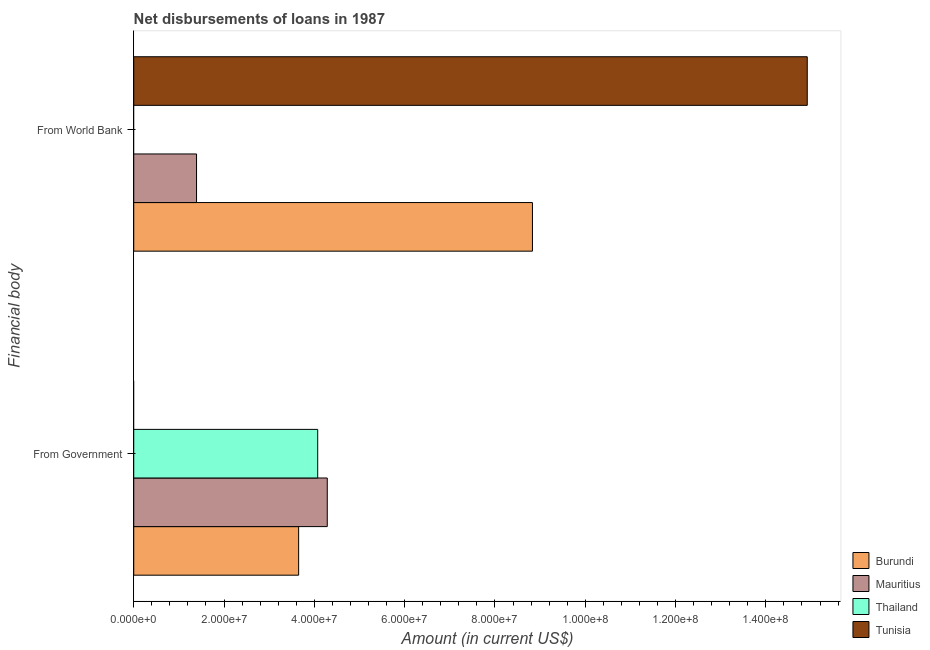How many different coloured bars are there?
Offer a very short reply. 4. Are the number of bars per tick equal to the number of legend labels?
Keep it short and to the point. No. Are the number of bars on each tick of the Y-axis equal?
Give a very brief answer. Yes. What is the label of the 2nd group of bars from the top?
Offer a very short reply. From Government. What is the net disbursements of loan from government in Mauritius?
Provide a succinct answer. 4.29e+07. Across all countries, what is the maximum net disbursements of loan from world bank?
Provide a short and direct response. 1.49e+08. In which country was the net disbursements of loan from government maximum?
Provide a succinct answer. Mauritius. What is the total net disbursements of loan from government in the graph?
Provide a short and direct response. 1.20e+08. What is the difference between the net disbursements of loan from world bank in Mauritius and that in Tunisia?
Provide a short and direct response. -1.35e+08. What is the difference between the net disbursements of loan from world bank in Burundi and the net disbursements of loan from government in Thailand?
Give a very brief answer. 4.76e+07. What is the average net disbursements of loan from government per country?
Provide a succinct answer. 3.00e+07. What is the difference between the net disbursements of loan from world bank and net disbursements of loan from government in Mauritius?
Make the answer very short. -2.89e+07. In how many countries, is the net disbursements of loan from world bank greater than 128000000 US$?
Make the answer very short. 1. What is the ratio of the net disbursements of loan from world bank in Tunisia to that in Mauritius?
Your response must be concise. 10.72. How many countries are there in the graph?
Provide a short and direct response. 4. What is the difference between two consecutive major ticks on the X-axis?
Provide a succinct answer. 2.00e+07. Are the values on the major ticks of X-axis written in scientific E-notation?
Offer a very short reply. Yes. Does the graph contain any zero values?
Offer a very short reply. Yes. Where does the legend appear in the graph?
Give a very brief answer. Bottom right. What is the title of the graph?
Your answer should be very brief. Net disbursements of loans in 1987. What is the label or title of the X-axis?
Make the answer very short. Amount (in current US$). What is the label or title of the Y-axis?
Your answer should be very brief. Financial body. What is the Amount (in current US$) of Burundi in From Government?
Your answer should be very brief. 3.65e+07. What is the Amount (in current US$) of Mauritius in From Government?
Your answer should be very brief. 4.29e+07. What is the Amount (in current US$) in Thailand in From Government?
Offer a very short reply. 4.07e+07. What is the Amount (in current US$) in Tunisia in From Government?
Offer a terse response. 0. What is the Amount (in current US$) of Burundi in From World Bank?
Your response must be concise. 8.83e+07. What is the Amount (in current US$) in Mauritius in From World Bank?
Keep it short and to the point. 1.39e+07. What is the Amount (in current US$) of Thailand in From World Bank?
Offer a terse response. 0. What is the Amount (in current US$) in Tunisia in From World Bank?
Your answer should be compact. 1.49e+08. Across all Financial body, what is the maximum Amount (in current US$) of Burundi?
Provide a short and direct response. 8.83e+07. Across all Financial body, what is the maximum Amount (in current US$) of Mauritius?
Your answer should be compact. 4.29e+07. Across all Financial body, what is the maximum Amount (in current US$) of Thailand?
Provide a short and direct response. 4.07e+07. Across all Financial body, what is the maximum Amount (in current US$) of Tunisia?
Offer a very short reply. 1.49e+08. Across all Financial body, what is the minimum Amount (in current US$) of Burundi?
Keep it short and to the point. 3.65e+07. Across all Financial body, what is the minimum Amount (in current US$) in Mauritius?
Your answer should be compact. 1.39e+07. Across all Financial body, what is the minimum Amount (in current US$) of Tunisia?
Your answer should be compact. 0. What is the total Amount (in current US$) of Burundi in the graph?
Your answer should be very brief. 1.25e+08. What is the total Amount (in current US$) of Mauritius in the graph?
Keep it short and to the point. 5.68e+07. What is the total Amount (in current US$) in Thailand in the graph?
Provide a short and direct response. 4.07e+07. What is the total Amount (in current US$) in Tunisia in the graph?
Offer a very short reply. 1.49e+08. What is the difference between the Amount (in current US$) in Burundi in From Government and that in From World Bank?
Give a very brief answer. -5.18e+07. What is the difference between the Amount (in current US$) in Mauritius in From Government and that in From World Bank?
Offer a terse response. 2.89e+07. What is the difference between the Amount (in current US$) in Burundi in From Government and the Amount (in current US$) in Mauritius in From World Bank?
Keep it short and to the point. 2.26e+07. What is the difference between the Amount (in current US$) in Burundi in From Government and the Amount (in current US$) in Tunisia in From World Bank?
Offer a very short reply. -1.13e+08. What is the difference between the Amount (in current US$) in Mauritius in From Government and the Amount (in current US$) in Tunisia in From World Bank?
Give a very brief answer. -1.06e+08. What is the difference between the Amount (in current US$) in Thailand in From Government and the Amount (in current US$) in Tunisia in From World Bank?
Keep it short and to the point. -1.08e+08. What is the average Amount (in current US$) in Burundi per Financial body?
Provide a short and direct response. 6.24e+07. What is the average Amount (in current US$) of Mauritius per Financial body?
Give a very brief answer. 2.84e+07. What is the average Amount (in current US$) in Thailand per Financial body?
Ensure brevity in your answer.  2.04e+07. What is the average Amount (in current US$) in Tunisia per Financial body?
Keep it short and to the point. 7.46e+07. What is the difference between the Amount (in current US$) of Burundi and Amount (in current US$) of Mauritius in From Government?
Give a very brief answer. -6.34e+06. What is the difference between the Amount (in current US$) in Burundi and Amount (in current US$) in Thailand in From Government?
Your answer should be compact. -4.22e+06. What is the difference between the Amount (in current US$) in Mauritius and Amount (in current US$) in Thailand in From Government?
Keep it short and to the point. 2.12e+06. What is the difference between the Amount (in current US$) of Burundi and Amount (in current US$) of Mauritius in From World Bank?
Give a very brief answer. 7.44e+07. What is the difference between the Amount (in current US$) of Burundi and Amount (in current US$) of Tunisia in From World Bank?
Give a very brief answer. -6.09e+07. What is the difference between the Amount (in current US$) in Mauritius and Amount (in current US$) in Tunisia in From World Bank?
Offer a terse response. -1.35e+08. What is the ratio of the Amount (in current US$) in Burundi in From Government to that in From World Bank?
Your response must be concise. 0.41. What is the ratio of the Amount (in current US$) in Mauritius in From Government to that in From World Bank?
Offer a very short reply. 3.08. What is the difference between the highest and the second highest Amount (in current US$) of Burundi?
Your response must be concise. 5.18e+07. What is the difference between the highest and the second highest Amount (in current US$) in Mauritius?
Your answer should be compact. 2.89e+07. What is the difference between the highest and the lowest Amount (in current US$) in Burundi?
Ensure brevity in your answer.  5.18e+07. What is the difference between the highest and the lowest Amount (in current US$) in Mauritius?
Your response must be concise. 2.89e+07. What is the difference between the highest and the lowest Amount (in current US$) of Thailand?
Offer a terse response. 4.07e+07. What is the difference between the highest and the lowest Amount (in current US$) of Tunisia?
Your response must be concise. 1.49e+08. 